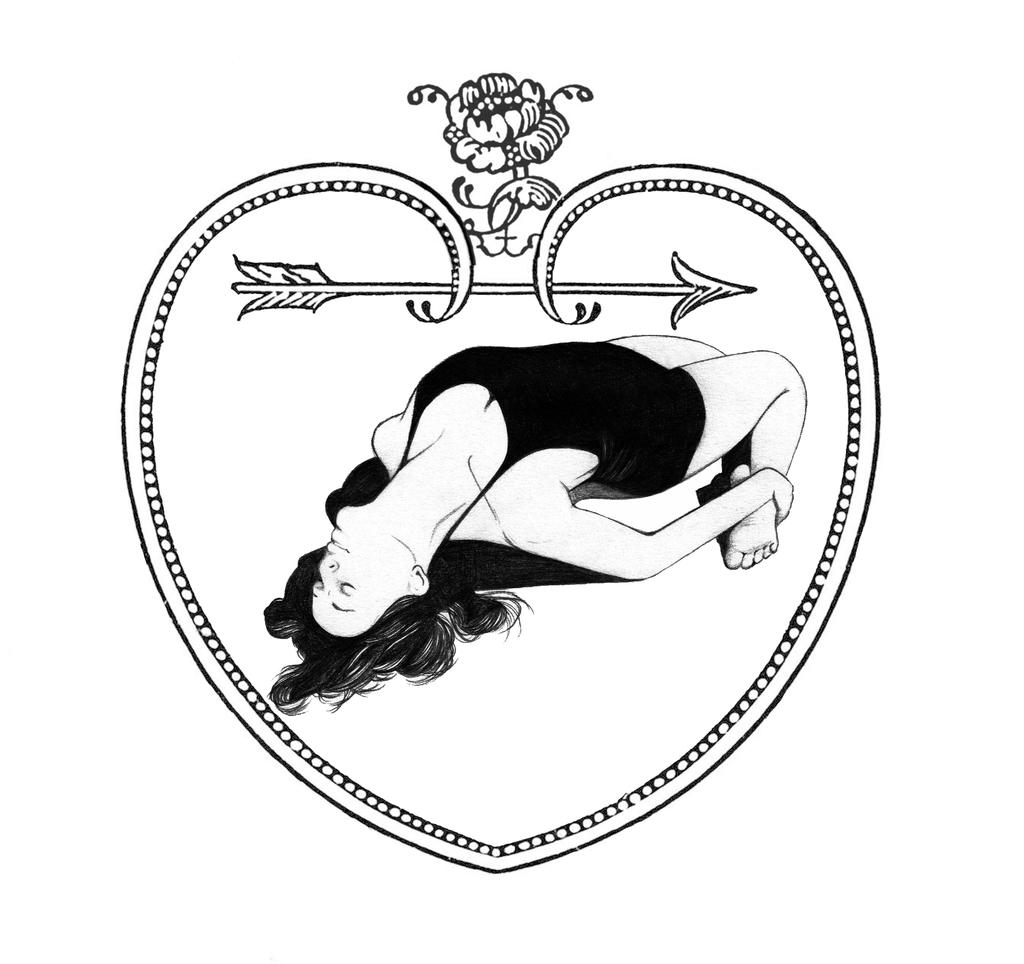What is the color scheme of the image? The image is black and white. What is depicted within the image? There is a drawing of a heart-shaped frame in the image. Are there any people in the image? Yes, there is a woman in the image. What type of substance is the woman holding in the image? There is no substance visible in the image; the woman is not holding anything. 